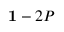Convert formula to latex. <formula><loc_0><loc_0><loc_500><loc_500>{ 1 } - 2 P</formula> 